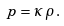<formula> <loc_0><loc_0><loc_500><loc_500>p = \kappa \, \rho \, .</formula> 